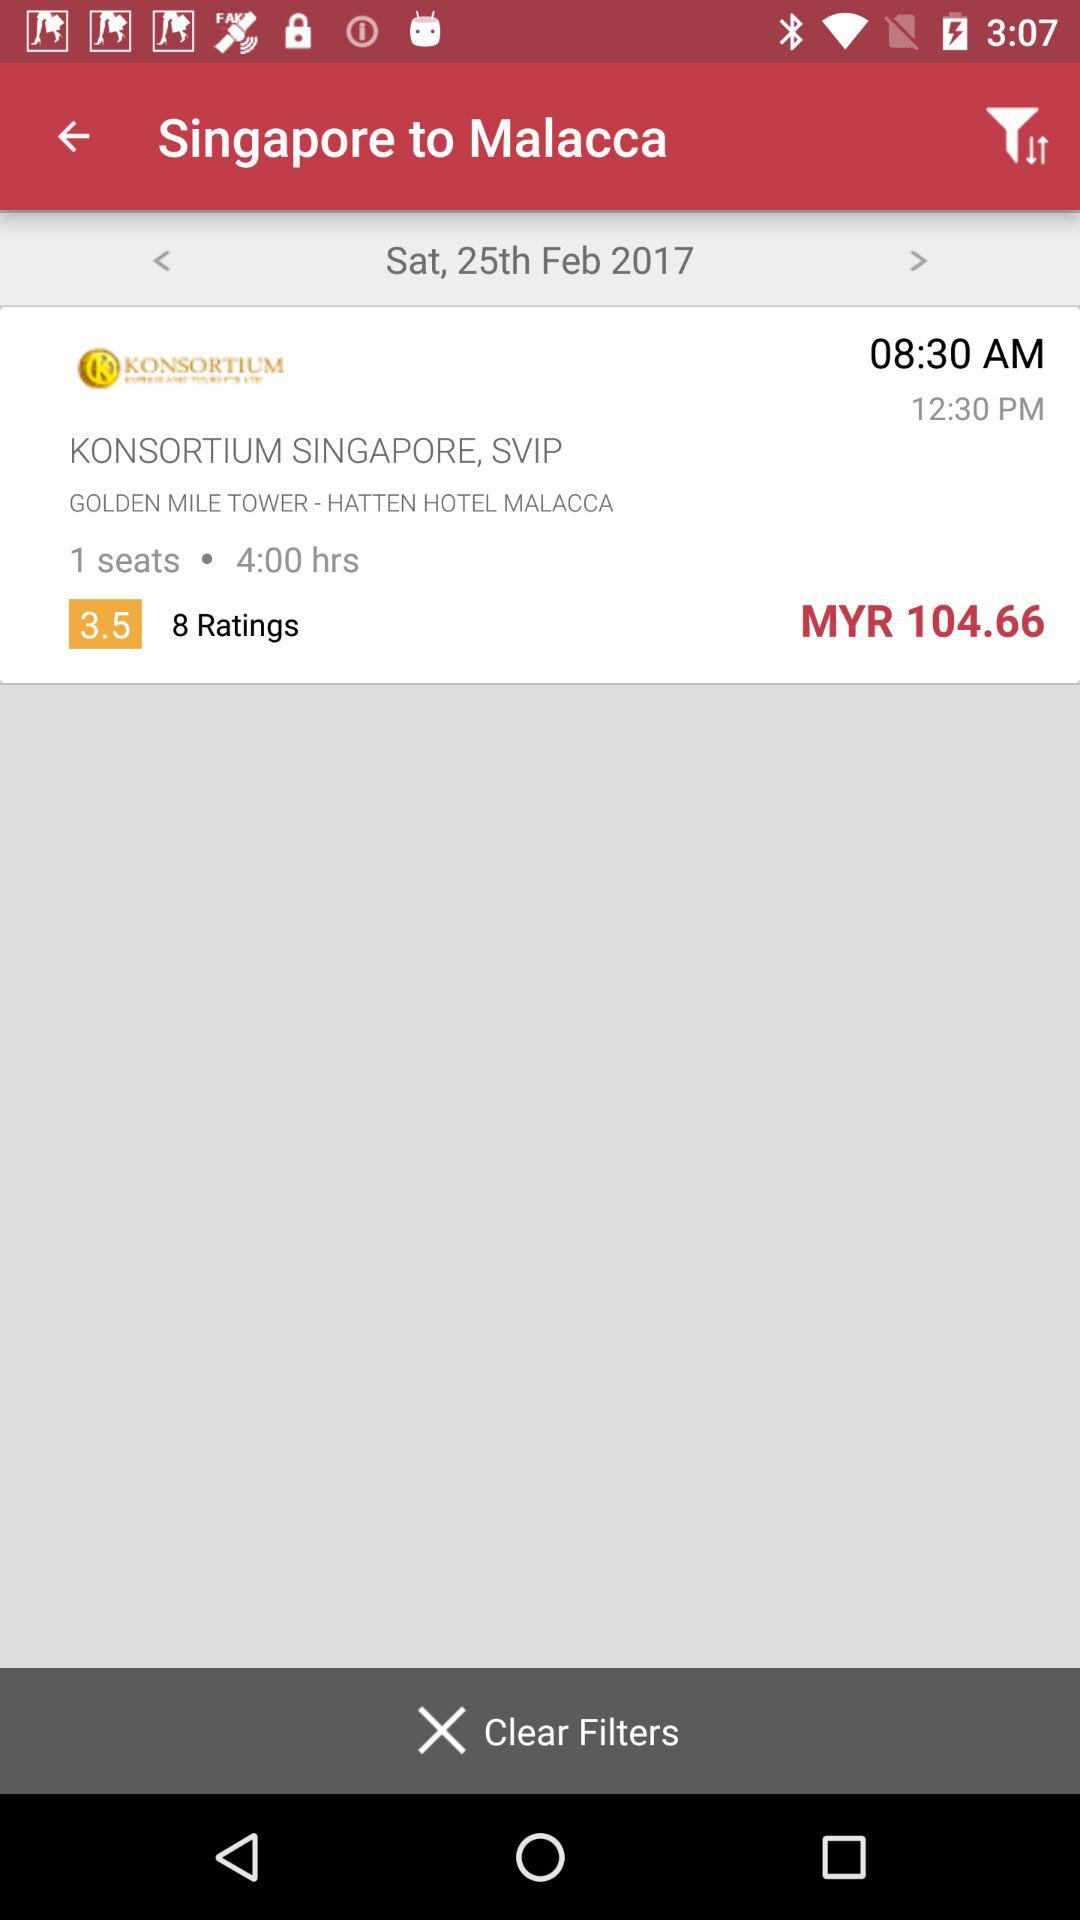How many more hours is the ride duration than the number of seats?
Answer the question using a single word or phrase. 3 